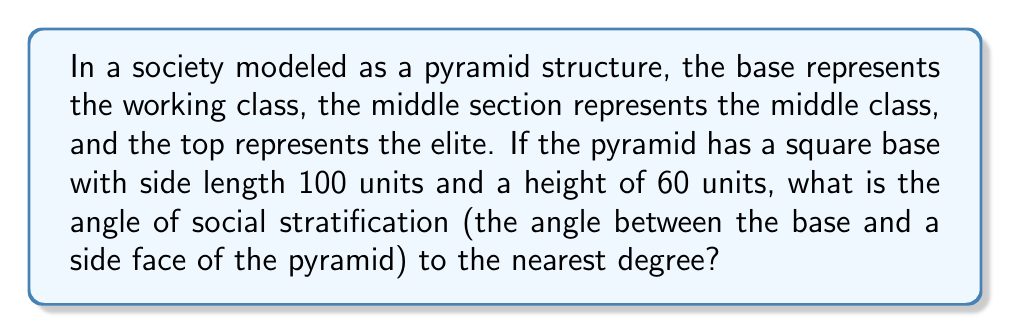Solve this math problem. To solve this problem, we need to follow these steps:

1. Recognize that we're dealing with a right triangle formed by:
   - The height of the pyramid (60 units)
   - Half the diagonal of the square base
   - The slant height (which represents the angle of social stratification)

2. Calculate half the diagonal of the square base:
   - Diagonal of a square = side length × $\sqrt{2}$
   - Half diagonal = $\frac{100\sqrt{2}}{2} = 50\sqrt{2}$ units

3. Use the arctangent function to find the angle:
   - $\tan(\theta) = \frac{\text{opposite}}{\text{adjacent}} = \frac{60}{50\sqrt{2}}$
   - $\theta = \arctan(\frac{60}{50\sqrt{2}})$

4. Calculate the result:
   $$\theta = \arctan(\frac{60}{50\sqrt{2}}) \approx 40.60^\circ$$

5. Round to the nearest degree:
   40.60° rounds to 41°

This angle represents the steepness of social stratification in the modeled society. A larger angle would indicate a more pronounced difference between social classes, while a smaller angle would suggest a more gradual transition between classes.

[asy]
import geometry;

size(200);
pair A = (0,0), B = (100,0), C = (50,60);
draw(A--B--C--A);
draw((-10,0)--(110,0), arrow=Arrow(TeXHead));
draw((50,-10)--(50,70), arrow=Arrow(TeXHead));
label("100", (50,0), S);
label("60", (50,30), E);
label("$\theta$", (10,10), NW);
[/asy]
Answer: 41° 